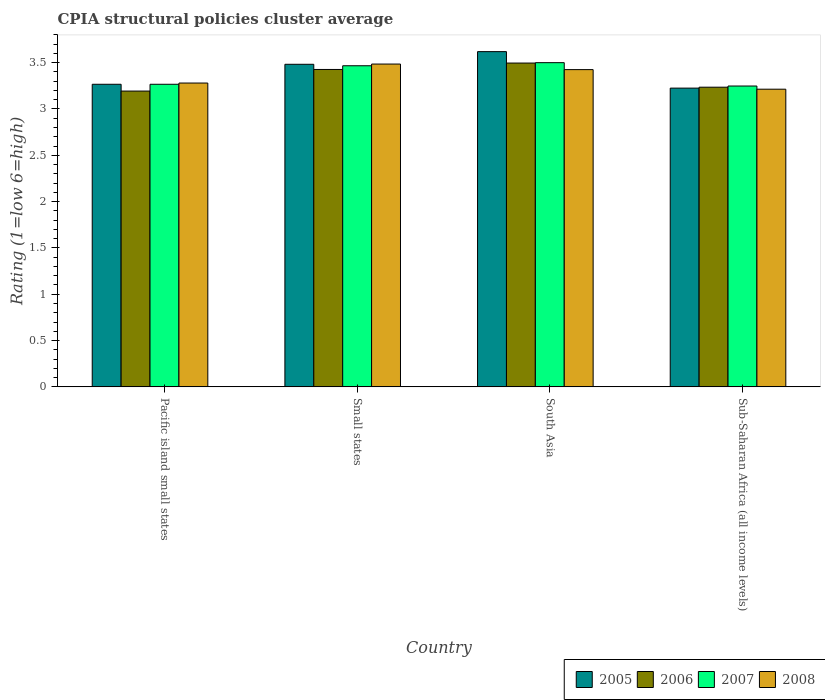How many different coloured bars are there?
Ensure brevity in your answer.  4. How many groups of bars are there?
Give a very brief answer. 4. Are the number of bars per tick equal to the number of legend labels?
Your answer should be compact. Yes. Are the number of bars on each tick of the X-axis equal?
Offer a very short reply. Yes. How many bars are there on the 1st tick from the left?
Your answer should be compact. 4. How many bars are there on the 4th tick from the right?
Your response must be concise. 4. What is the label of the 1st group of bars from the left?
Your answer should be very brief. Pacific island small states. What is the CPIA rating in 2006 in Small states?
Provide a short and direct response. 3.43. Across all countries, what is the maximum CPIA rating in 2007?
Offer a terse response. 3.5. Across all countries, what is the minimum CPIA rating in 2008?
Keep it short and to the point. 3.21. In which country was the CPIA rating in 2005 minimum?
Offer a very short reply. Sub-Saharan Africa (all income levels). What is the total CPIA rating in 2006 in the graph?
Your answer should be compact. 13.35. What is the difference between the CPIA rating in 2006 in Pacific island small states and that in Sub-Saharan Africa (all income levels)?
Offer a terse response. -0.04. What is the difference between the CPIA rating in 2005 in Sub-Saharan Africa (all income levels) and the CPIA rating in 2006 in Small states?
Your response must be concise. -0.2. What is the average CPIA rating in 2005 per country?
Offer a very short reply. 3.4. What is the difference between the CPIA rating of/in 2007 and CPIA rating of/in 2008 in Sub-Saharan Africa (all income levels)?
Your answer should be compact. 0.03. In how many countries, is the CPIA rating in 2005 greater than 3.5?
Offer a very short reply. 1. What is the ratio of the CPIA rating in 2008 in Pacific island small states to that in Sub-Saharan Africa (all income levels)?
Your answer should be compact. 1.02. What is the difference between the highest and the second highest CPIA rating in 2006?
Offer a terse response. -0.07. What is the difference between the highest and the lowest CPIA rating in 2007?
Provide a succinct answer. 0.25. Is the sum of the CPIA rating in 2005 in Pacific island small states and South Asia greater than the maximum CPIA rating in 2008 across all countries?
Keep it short and to the point. Yes. Is it the case that in every country, the sum of the CPIA rating in 2006 and CPIA rating in 2007 is greater than the sum of CPIA rating in 2008 and CPIA rating in 2005?
Offer a very short reply. No. What does the 4th bar from the left in Pacific island small states represents?
Keep it short and to the point. 2008. What is the difference between two consecutive major ticks on the Y-axis?
Your response must be concise. 0.5. Are the values on the major ticks of Y-axis written in scientific E-notation?
Your answer should be compact. No. Does the graph contain any zero values?
Keep it short and to the point. No. Where does the legend appear in the graph?
Offer a terse response. Bottom right. How are the legend labels stacked?
Keep it short and to the point. Horizontal. What is the title of the graph?
Provide a short and direct response. CPIA structural policies cluster average. What is the label or title of the Y-axis?
Make the answer very short. Rating (1=low 6=high). What is the Rating (1=low 6=high) of 2005 in Pacific island small states?
Offer a very short reply. 3.27. What is the Rating (1=low 6=high) of 2006 in Pacific island small states?
Provide a succinct answer. 3.19. What is the Rating (1=low 6=high) of 2007 in Pacific island small states?
Ensure brevity in your answer.  3.27. What is the Rating (1=low 6=high) of 2008 in Pacific island small states?
Your response must be concise. 3.28. What is the Rating (1=low 6=high) in 2005 in Small states?
Offer a very short reply. 3.48. What is the Rating (1=low 6=high) of 2006 in Small states?
Provide a succinct answer. 3.43. What is the Rating (1=low 6=high) in 2007 in Small states?
Make the answer very short. 3.47. What is the Rating (1=low 6=high) in 2008 in Small states?
Offer a very short reply. 3.48. What is the Rating (1=low 6=high) in 2005 in South Asia?
Give a very brief answer. 3.62. What is the Rating (1=low 6=high) of 2006 in South Asia?
Give a very brief answer. 3.5. What is the Rating (1=low 6=high) of 2008 in South Asia?
Your response must be concise. 3.42. What is the Rating (1=low 6=high) of 2005 in Sub-Saharan Africa (all income levels)?
Make the answer very short. 3.23. What is the Rating (1=low 6=high) of 2006 in Sub-Saharan Africa (all income levels)?
Provide a short and direct response. 3.24. What is the Rating (1=low 6=high) in 2007 in Sub-Saharan Africa (all income levels)?
Offer a very short reply. 3.25. What is the Rating (1=low 6=high) of 2008 in Sub-Saharan Africa (all income levels)?
Provide a succinct answer. 3.21. Across all countries, what is the maximum Rating (1=low 6=high) in 2005?
Your answer should be very brief. 3.62. Across all countries, what is the maximum Rating (1=low 6=high) of 2006?
Ensure brevity in your answer.  3.5. Across all countries, what is the maximum Rating (1=low 6=high) in 2007?
Your answer should be compact. 3.5. Across all countries, what is the maximum Rating (1=low 6=high) in 2008?
Provide a short and direct response. 3.48. Across all countries, what is the minimum Rating (1=low 6=high) of 2005?
Ensure brevity in your answer.  3.23. Across all countries, what is the minimum Rating (1=low 6=high) of 2006?
Offer a terse response. 3.19. Across all countries, what is the minimum Rating (1=low 6=high) in 2007?
Offer a terse response. 3.25. Across all countries, what is the minimum Rating (1=low 6=high) in 2008?
Your response must be concise. 3.21. What is the total Rating (1=low 6=high) of 2005 in the graph?
Your response must be concise. 13.59. What is the total Rating (1=low 6=high) of 2006 in the graph?
Provide a short and direct response. 13.35. What is the total Rating (1=low 6=high) of 2007 in the graph?
Provide a succinct answer. 13.48. What is the total Rating (1=low 6=high) in 2008 in the graph?
Give a very brief answer. 13.4. What is the difference between the Rating (1=low 6=high) of 2005 in Pacific island small states and that in Small states?
Provide a succinct answer. -0.22. What is the difference between the Rating (1=low 6=high) in 2006 in Pacific island small states and that in Small states?
Your answer should be compact. -0.23. What is the difference between the Rating (1=low 6=high) of 2008 in Pacific island small states and that in Small states?
Give a very brief answer. -0.2. What is the difference between the Rating (1=low 6=high) of 2005 in Pacific island small states and that in South Asia?
Provide a succinct answer. -0.35. What is the difference between the Rating (1=low 6=high) of 2006 in Pacific island small states and that in South Asia?
Provide a succinct answer. -0.3. What is the difference between the Rating (1=low 6=high) of 2007 in Pacific island small states and that in South Asia?
Keep it short and to the point. -0.23. What is the difference between the Rating (1=low 6=high) of 2008 in Pacific island small states and that in South Asia?
Give a very brief answer. -0.14. What is the difference between the Rating (1=low 6=high) of 2005 in Pacific island small states and that in Sub-Saharan Africa (all income levels)?
Your answer should be compact. 0.04. What is the difference between the Rating (1=low 6=high) of 2006 in Pacific island small states and that in Sub-Saharan Africa (all income levels)?
Your response must be concise. -0.04. What is the difference between the Rating (1=low 6=high) of 2007 in Pacific island small states and that in Sub-Saharan Africa (all income levels)?
Provide a short and direct response. 0.02. What is the difference between the Rating (1=low 6=high) of 2008 in Pacific island small states and that in Sub-Saharan Africa (all income levels)?
Offer a very short reply. 0.07. What is the difference between the Rating (1=low 6=high) of 2005 in Small states and that in South Asia?
Your answer should be compact. -0.14. What is the difference between the Rating (1=low 6=high) of 2006 in Small states and that in South Asia?
Your answer should be compact. -0.07. What is the difference between the Rating (1=low 6=high) of 2007 in Small states and that in South Asia?
Your answer should be compact. -0.03. What is the difference between the Rating (1=low 6=high) in 2005 in Small states and that in Sub-Saharan Africa (all income levels)?
Provide a short and direct response. 0.26. What is the difference between the Rating (1=low 6=high) of 2006 in Small states and that in Sub-Saharan Africa (all income levels)?
Make the answer very short. 0.19. What is the difference between the Rating (1=low 6=high) in 2007 in Small states and that in Sub-Saharan Africa (all income levels)?
Offer a terse response. 0.22. What is the difference between the Rating (1=low 6=high) of 2008 in Small states and that in Sub-Saharan Africa (all income levels)?
Keep it short and to the point. 0.27. What is the difference between the Rating (1=low 6=high) of 2005 in South Asia and that in Sub-Saharan Africa (all income levels)?
Give a very brief answer. 0.39. What is the difference between the Rating (1=low 6=high) of 2006 in South Asia and that in Sub-Saharan Africa (all income levels)?
Ensure brevity in your answer.  0.26. What is the difference between the Rating (1=low 6=high) of 2007 in South Asia and that in Sub-Saharan Africa (all income levels)?
Offer a terse response. 0.25. What is the difference between the Rating (1=low 6=high) in 2008 in South Asia and that in Sub-Saharan Africa (all income levels)?
Offer a very short reply. 0.21. What is the difference between the Rating (1=low 6=high) in 2005 in Pacific island small states and the Rating (1=low 6=high) in 2006 in Small states?
Ensure brevity in your answer.  -0.16. What is the difference between the Rating (1=low 6=high) in 2005 in Pacific island small states and the Rating (1=low 6=high) in 2008 in Small states?
Your response must be concise. -0.22. What is the difference between the Rating (1=low 6=high) of 2006 in Pacific island small states and the Rating (1=low 6=high) of 2007 in Small states?
Keep it short and to the point. -0.27. What is the difference between the Rating (1=low 6=high) of 2006 in Pacific island small states and the Rating (1=low 6=high) of 2008 in Small states?
Your answer should be very brief. -0.29. What is the difference between the Rating (1=low 6=high) in 2007 in Pacific island small states and the Rating (1=low 6=high) in 2008 in Small states?
Your answer should be compact. -0.22. What is the difference between the Rating (1=low 6=high) in 2005 in Pacific island small states and the Rating (1=low 6=high) in 2006 in South Asia?
Offer a terse response. -0.23. What is the difference between the Rating (1=low 6=high) in 2005 in Pacific island small states and the Rating (1=low 6=high) in 2007 in South Asia?
Offer a very short reply. -0.23. What is the difference between the Rating (1=low 6=high) of 2005 in Pacific island small states and the Rating (1=low 6=high) of 2008 in South Asia?
Give a very brief answer. -0.16. What is the difference between the Rating (1=low 6=high) of 2006 in Pacific island small states and the Rating (1=low 6=high) of 2007 in South Asia?
Make the answer very short. -0.31. What is the difference between the Rating (1=low 6=high) of 2006 in Pacific island small states and the Rating (1=low 6=high) of 2008 in South Asia?
Keep it short and to the point. -0.23. What is the difference between the Rating (1=low 6=high) in 2007 in Pacific island small states and the Rating (1=low 6=high) in 2008 in South Asia?
Ensure brevity in your answer.  -0.16. What is the difference between the Rating (1=low 6=high) of 2005 in Pacific island small states and the Rating (1=low 6=high) of 2006 in Sub-Saharan Africa (all income levels)?
Your answer should be compact. 0.03. What is the difference between the Rating (1=low 6=high) in 2005 in Pacific island small states and the Rating (1=low 6=high) in 2007 in Sub-Saharan Africa (all income levels)?
Your answer should be compact. 0.02. What is the difference between the Rating (1=low 6=high) of 2005 in Pacific island small states and the Rating (1=low 6=high) of 2008 in Sub-Saharan Africa (all income levels)?
Give a very brief answer. 0.05. What is the difference between the Rating (1=low 6=high) of 2006 in Pacific island small states and the Rating (1=low 6=high) of 2007 in Sub-Saharan Africa (all income levels)?
Provide a succinct answer. -0.05. What is the difference between the Rating (1=low 6=high) of 2006 in Pacific island small states and the Rating (1=low 6=high) of 2008 in Sub-Saharan Africa (all income levels)?
Your response must be concise. -0.02. What is the difference between the Rating (1=low 6=high) in 2007 in Pacific island small states and the Rating (1=low 6=high) in 2008 in Sub-Saharan Africa (all income levels)?
Ensure brevity in your answer.  0.05. What is the difference between the Rating (1=low 6=high) of 2005 in Small states and the Rating (1=low 6=high) of 2006 in South Asia?
Offer a terse response. -0.01. What is the difference between the Rating (1=low 6=high) of 2005 in Small states and the Rating (1=low 6=high) of 2007 in South Asia?
Offer a very short reply. -0.02. What is the difference between the Rating (1=low 6=high) in 2005 in Small states and the Rating (1=low 6=high) in 2008 in South Asia?
Give a very brief answer. 0.06. What is the difference between the Rating (1=low 6=high) of 2006 in Small states and the Rating (1=low 6=high) of 2007 in South Asia?
Offer a very short reply. -0.07. What is the difference between the Rating (1=low 6=high) of 2006 in Small states and the Rating (1=low 6=high) of 2008 in South Asia?
Give a very brief answer. 0. What is the difference between the Rating (1=low 6=high) of 2007 in Small states and the Rating (1=low 6=high) of 2008 in South Asia?
Offer a terse response. 0.04. What is the difference between the Rating (1=low 6=high) in 2005 in Small states and the Rating (1=low 6=high) in 2006 in Sub-Saharan Africa (all income levels)?
Ensure brevity in your answer.  0.25. What is the difference between the Rating (1=low 6=high) of 2005 in Small states and the Rating (1=low 6=high) of 2007 in Sub-Saharan Africa (all income levels)?
Your answer should be compact. 0.23. What is the difference between the Rating (1=low 6=high) in 2005 in Small states and the Rating (1=low 6=high) in 2008 in Sub-Saharan Africa (all income levels)?
Provide a short and direct response. 0.27. What is the difference between the Rating (1=low 6=high) of 2006 in Small states and the Rating (1=low 6=high) of 2007 in Sub-Saharan Africa (all income levels)?
Your response must be concise. 0.18. What is the difference between the Rating (1=low 6=high) in 2006 in Small states and the Rating (1=low 6=high) in 2008 in Sub-Saharan Africa (all income levels)?
Ensure brevity in your answer.  0.21. What is the difference between the Rating (1=low 6=high) in 2007 in Small states and the Rating (1=low 6=high) in 2008 in Sub-Saharan Africa (all income levels)?
Offer a very short reply. 0.25. What is the difference between the Rating (1=low 6=high) in 2005 in South Asia and the Rating (1=low 6=high) in 2006 in Sub-Saharan Africa (all income levels)?
Your response must be concise. 0.38. What is the difference between the Rating (1=low 6=high) in 2005 in South Asia and the Rating (1=low 6=high) in 2007 in Sub-Saharan Africa (all income levels)?
Provide a succinct answer. 0.37. What is the difference between the Rating (1=low 6=high) in 2005 in South Asia and the Rating (1=low 6=high) in 2008 in Sub-Saharan Africa (all income levels)?
Your answer should be compact. 0.41. What is the difference between the Rating (1=low 6=high) in 2006 in South Asia and the Rating (1=low 6=high) in 2007 in Sub-Saharan Africa (all income levels)?
Your answer should be very brief. 0.25. What is the difference between the Rating (1=low 6=high) of 2006 in South Asia and the Rating (1=low 6=high) of 2008 in Sub-Saharan Africa (all income levels)?
Your response must be concise. 0.28. What is the difference between the Rating (1=low 6=high) of 2007 in South Asia and the Rating (1=low 6=high) of 2008 in Sub-Saharan Africa (all income levels)?
Keep it short and to the point. 0.29. What is the average Rating (1=low 6=high) in 2005 per country?
Give a very brief answer. 3.4. What is the average Rating (1=low 6=high) in 2006 per country?
Your answer should be compact. 3.34. What is the average Rating (1=low 6=high) of 2007 per country?
Provide a short and direct response. 3.37. What is the average Rating (1=low 6=high) of 2008 per country?
Offer a very short reply. 3.35. What is the difference between the Rating (1=low 6=high) of 2005 and Rating (1=low 6=high) of 2006 in Pacific island small states?
Ensure brevity in your answer.  0.07. What is the difference between the Rating (1=low 6=high) in 2005 and Rating (1=low 6=high) in 2007 in Pacific island small states?
Your answer should be very brief. 0. What is the difference between the Rating (1=low 6=high) of 2005 and Rating (1=low 6=high) of 2008 in Pacific island small states?
Provide a short and direct response. -0.01. What is the difference between the Rating (1=low 6=high) of 2006 and Rating (1=low 6=high) of 2007 in Pacific island small states?
Make the answer very short. -0.07. What is the difference between the Rating (1=low 6=high) in 2006 and Rating (1=low 6=high) in 2008 in Pacific island small states?
Give a very brief answer. -0.09. What is the difference between the Rating (1=low 6=high) of 2007 and Rating (1=low 6=high) of 2008 in Pacific island small states?
Keep it short and to the point. -0.01. What is the difference between the Rating (1=low 6=high) of 2005 and Rating (1=low 6=high) of 2006 in Small states?
Provide a short and direct response. 0.06. What is the difference between the Rating (1=low 6=high) of 2005 and Rating (1=low 6=high) of 2007 in Small states?
Your answer should be very brief. 0.02. What is the difference between the Rating (1=low 6=high) of 2005 and Rating (1=low 6=high) of 2008 in Small states?
Provide a succinct answer. -0. What is the difference between the Rating (1=low 6=high) of 2006 and Rating (1=low 6=high) of 2007 in Small states?
Your answer should be compact. -0.04. What is the difference between the Rating (1=low 6=high) of 2006 and Rating (1=low 6=high) of 2008 in Small states?
Your response must be concise. -0.06. What is the difference between the Rating (1=low 6=high) of 2007 and Rating (1=low 6=high) of 2008 in Small states?
Give a very brief answer. -0.02. What is the difference between the Rating (1=low 6=high) in 2005 and Rating (1=low 6=high) in 2006 in South Asia?
Provide a short and direct response. 0.12. What is the difference between the Rating (1=low 6=high) in 2005 and Rating (1=low 6=high) in 2007 in South Asia?
Your response must be concise. 0.12. What is the difference between the Rating (1=low 6=high) of 2005 and Rating (1=low 6=high) of 2008 in South Asia?
Your answer should be very brief. 0.19. What is the difference between the Rating (1=low 6=high) in 2006 and Rating (1=low 6=high) in 2007 in South Asia?
Provide a short and direct response. -0. What is the difference between the Rating (1=low 6=high) of 2006 and Rating (1=low 6=high) of 2008 in South Asia?
Your answer should be very brief. 0.07. What is the difference between the Rating (1=low 6=high) of 2007 and Rating (1=low 6=high) of 2008 in South Asia?
Keep it short and to the point. 0.07. What is the difference between the Rating (1=low 6=high) in 2005 and Rating (1=low 6=high) in 2006 in Sub-Saharan Africa (all income levels)?
Your response must be concise. -0.01. What is the difference between the Rating (1=low 6=high) of 2005 and Rating (1=low 6=high) of 2007 in Sub-Saharan Africa (all income levels)?
Your answer should be very brief. -0.02. What is the difference between the Rating (1=low 6=high) in 2005 and Rating (1=low 6=high) in 2008 in Sub-Saharan Africa (all income levels)?
Offer a very short reply. 0.01. What is the difference between the Rating (1=low 6=high) in 2006 and Rating (1=low 6=high) in 2007 in Sub-Saharan Africa (all income levels)?
Your answer should be compact. -0.01. What is the difference between the Rating (1=low 6=high) in 2006 and Rating (1=low 6=high) in 2008 in Sub-Saharan Africa (all income levels)?
Offer a very short reply. 0.02. What is the difference between the Rating (1=low 6=high) of 2007 and Rating (1=low 6=high) of 2008 in Sub-Saharan Africa (all income levels)?
Your answer should be compact. 0.03. What is the ratio of the Rating (1=low 6=high) in 2005 in Pacific island small states to that in Small states?
Provide a succinct answer. 0.94. What is the ratio of the Rating (1=low 6=high) in 2006 in Pacific island small states to that in Small states?
Offer a terse response. 0.93. What is the ratio of the Rating (1=low 6=high) of 2007 in Pacific island small states to that in Small states?
Provide a succinct answer. 0.94. What is the ratio of the Rating (1=low 6=high) of 2005 in Pacific island small states to that in South Asia?
Ensure brevity in your answer.  0.9. What is the ratio of the Rating (1=low 6=high) in 2006 in Pacific island small states to that in South Asia?
Your answer should be compact. 0.91. What is the ratio of the Rating (1=low 6=high) in 2007 in Pacific island small states to that in South Asia?
Provide a succinct answer. 0.93. What is the ratio of the Rating (1=low 6=high) of 2008 in Pacific island small states to that in South Asia?
Provide a short and direct response. 0.96. What is the ratio of the Rating (1=low 6=high) in 2005 in Pacific island small states to that in Sub-Saharan Africa (all income levels)?
Ensure brevity in your answer.  1.01. What is the ratio of the Rating (1=low 6=high) in 2006 in Pacific island small states to that in Sub-Saharan Africa (all income levels)?
Provide a succinct answer. 0.99. What is the ratio of the Rating (1=low 6=high) of 2007 in Pacific island small states to that in Sub-Saharan Africa (all income levels)?
Your response must be concise. 1.01. What is the ratio of the Rating (1=low 6=high) in 2008 in Pacific island small states to that in Sub-Saharan Africa (all income levels)?
Offer a terse response. 1.02. What is the ratio of the Rating (1=low 6=high) in 2005 in Small states to that in South Asia?
Your answer should be very brief. 0.96. What is the ratio of the Rating (1=low 6=high) of 2006 in Small states to that in South Asia?
Ensure brevity in your answer.  0.98. What is the ratio of the Rating (1=low 6=high) of 2008 in Small states to that in South Asia?
Provide a short and direct response. 1.02. What is the ratio of the Rating (1=low 6=high) in 2005 in Small states to that in Sub-Saharan Africa (all income levels)?
Give a very brief answer. 1.08. What is the ratio of the Rating (1=low 6=high) of 2006 in Small states to that in Sub-Saharan Africa (all income levels)?
Offer a terse response. 1.06. What is the ratio of the Rating (1=low 6=high) of 2007 in Small states to that in Sub-Saharan Africa (all income levels)?
Offer a terse response. 1.07. What is the ratio of the Rating (1=low 6=high) of 2008 in Small states to that in Sub-Saharan Africa (all income levels)?
Your answer should be very brief. 1.08. What is the ratio of the Rating (1=low 6=high) of 2005 in South Asia to that in Sub-Saharan Africa (all income levels)?
Keep it short and to the point. 1.12. What is the ratio of the Rating (1=low 6=high) of 2006 in South Asia to that in Sub-Saharan Africa (all income levels)?
Offer a very short reply. 1.08. What is the ratio of the Rating (1=low 6=high) of 2007 in South Asia to that in Sub-Saharan Africa (all income levels)?
Your response must be concise. 1.08. What is the ratio of the Rating (1=low 6=high) of 2008 in South Asia to that in Sub-Saharan Africa (all income levels)?
Your response must be concise. 1.07. What is the difference between the highest and the second highest Rating (1=low 6=high) in 2005?
Offer a terse response. 0.14. What is the difference between the highest and the second highest Rating (1=low 6=high) of 2006?
Your response must be concise. 0.07. What is the difference between the highest and the lowest Rating (1=low 6=high) of 2005?
Provide a succinct answer. 0.39. What is the difference between the highest and the lowest Rating (1=low 6=high) in 2006?
Your response must be concise. 0.3. What is the difference between the highest and the lowest Rating (1=low 6=high) of 2007?
Your response must be concise. 0.25. What is the difference between the highest and the lowest Rating (1=low 6=high) in 2008?
Keep it short and to the point. 0.27. 